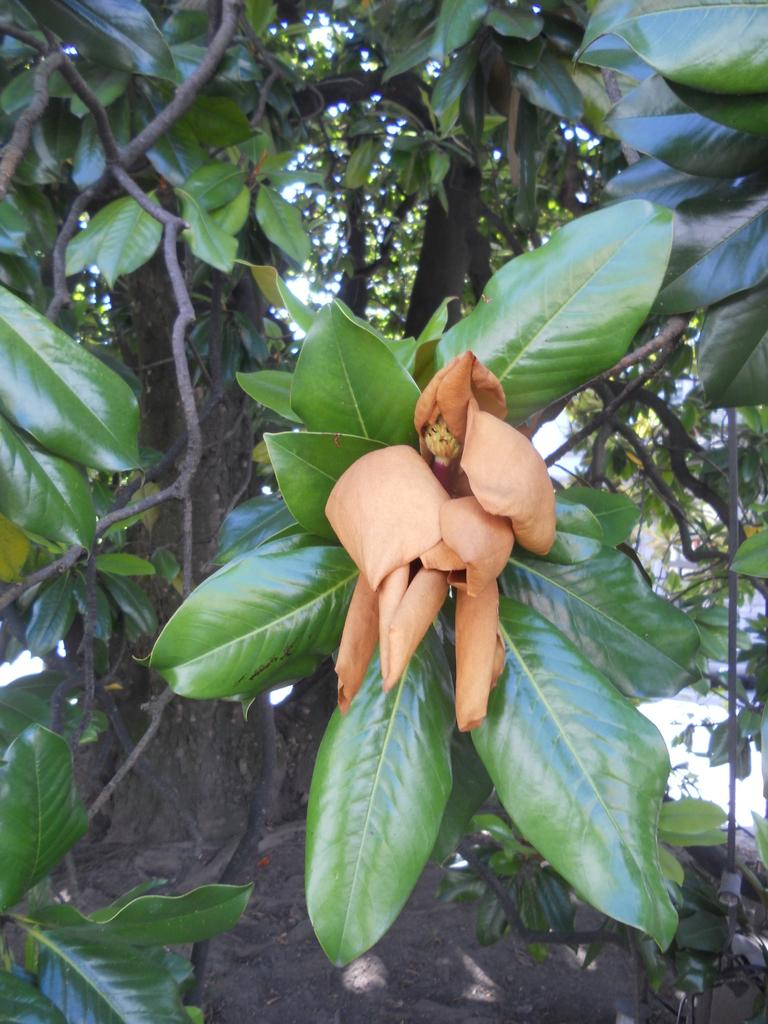What is the main subject in the center of the image? There are branches with leaves in the center of the image. What can be seen in the background of the image? There are trees visible in the background of the image. What type of skirt is hanging on the branches in the image? There is no skirt present in the image; it features branches with leaves and trees in the background. What sound can be heard during a thunderstorm in the image? There is no thunderstorm or sound in the image. 